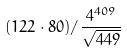<formula> <loc_0><loc_0><loc_500><loc_500>( 1 2 2 \cdot 8 0 ) / \frac { 4 ^ { 4 0 9 } } { \sqrt { 4 4 9 } }</formula> 